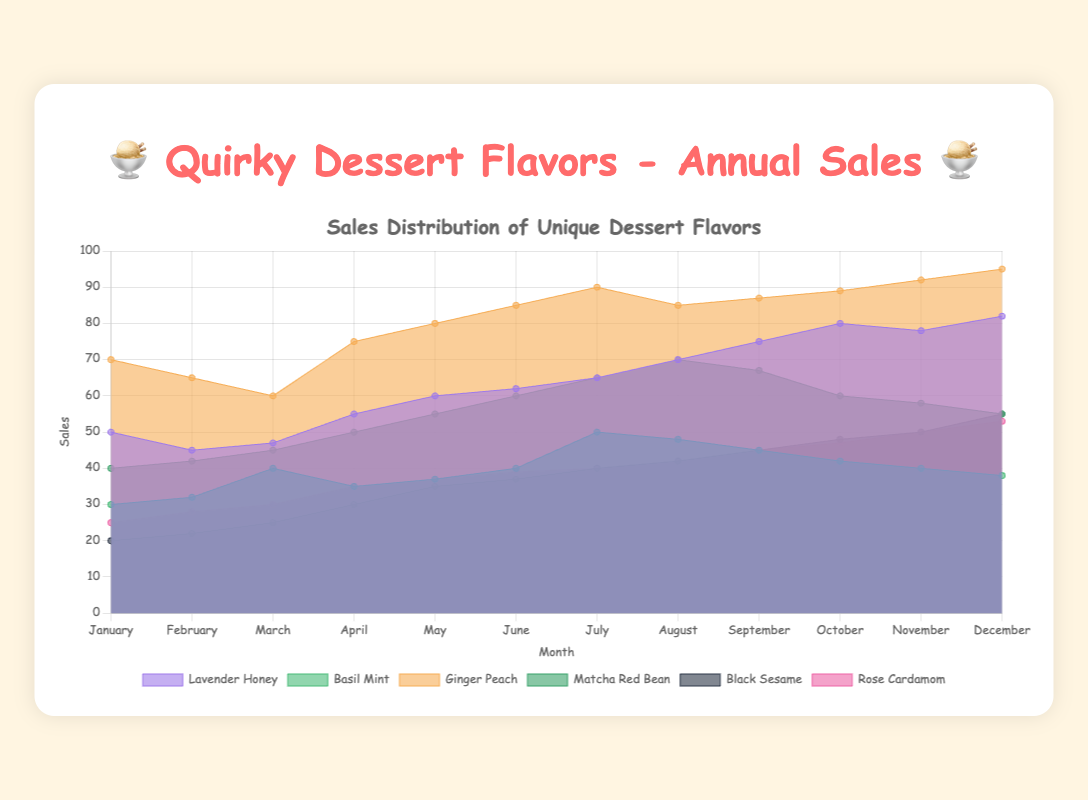What's the most popular dessert flavor in December? Referring to the area chart, we look for the highest peak for the month of December across all flavors. The "Ginger Peach" flavor reaches 95 in December, which is the highest among all flavors.
Answer: Ginger Peach During which month does "Lavender Honey" have the highest sales? Looking at the trend of the "Lavender Honey" line, we identify the peak value. The highest sales for "Lavender Honey" occur in December with a value of 82.
Answer: December Which flavor shows the largest increase in sales from January to December? To find this, we calculate the difference between the sales in January and December for each flavor. "Ginger Peach" goes from 70 in January to 95 in December, showing an increase of 25. This is the largest increase among all flavors.
Answer: Ginger Peach Which two flavors have the closest sales in July? For July, the sales values are: "Lavender Honey" (65), "Basil Mint" (50), "Ginger Peach" (90), "Matcha Red Bean" (65), "Black Sesame" (40), and "Rose Cardamom" (40). "Black Sesame" and "Rose Cardamom" both have sales of 40, making them the closest in value.
Answer: Black Sesame and Rose Cardamom In which month does "Matcha Red Bean" peak, and what is the peak value? Observing the trend of "Matcha Red Bean", the peak is in August with a sales value of 70.
Answer: August, 70 How do the sales of "Basil Mint" in June compare to "Rose Cardamom" in November? Looking at the chart, "Basil Mint" in June has a value of 40, while "Rose Cardamom" in November has a value of 50. "Rose Cardamom" in November has higher sales compared to "Basil Mint" in June.
Answer: Rose Cardamom is higher What is the average sales of "Black Sesame" over the year? Summing up the monthly sales for "Black Sesame" (20 + 22 + 25 + 30 + 35 + 37 + 40 + 42 + 45 + 48 + 50 + 55) equals 449. Dividing this by 12 months, we get the average as 449/12 ≈ 37.42.
Answer: 37.42 Which month shows the highest cumulative sales for all flavors combined? To find this, sum the sales of all flavors for each month:
- January: 50 + 30 + 70 + 40 + 20 + 25 = 235
- February: 45 + 32 + 65 + 42 + 22 + 28 = 234
- ... (continue for each month)
After summing each month, December has the highest cumulative sales at 378.
Answer: December What's the total sales of "Ginger Peach" from June to August? Summing the values from June (85), July (90), and August (85) gives 85 + 90 + 85 = 260.
Answer: 260 